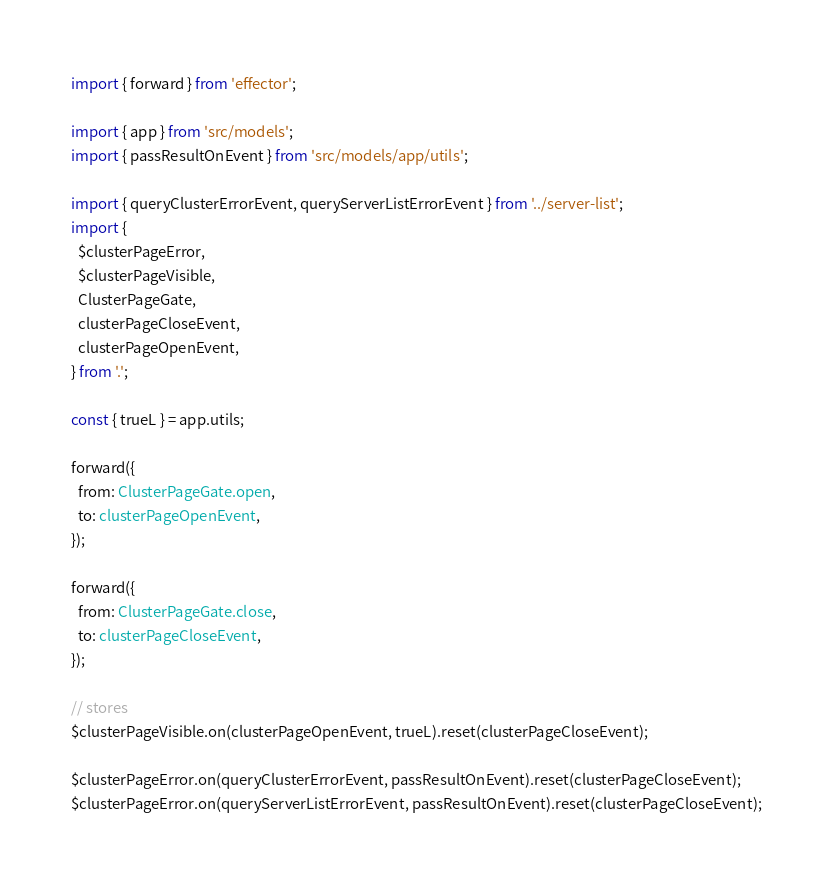<code> <loc_0><loc_0><loc_500><loc_500><_TypeScript_>import { forward } from 'effector';

import { app } from 'src/models';
import { passResultOnEvent } from 'src/models/app/utils';

import { queryClusterErrorEvent, queryServerListErrorEvent } from '../server-list';
import {
  $clusterPageError,
  $clusterPageVisible,
  ClusterPageGate,
  clusterPageCloseEvent,
  clusterPageOpenEvent,
} from '.';

const { trueL } = app.utils;

forward({
  from: ClusterPageGate.open,
  to: clusterPageOpenEvent,
});

forward({
  from: ClusterPageGate.close,
  to: clusterPageCloseEvent,
});

// stores
$clusterPageVisible.on(clusterPageOpenEvent, trueL).reset(clusterPageCloseEvent);

$clusterPageError.on(queryClusterErrorEvent, passResultOnEvent).reset(clusterPageCloseEvent);
$clusterPageError.on(queryServerListErrorEvent, passResultOnEvent).reset(clusterPageCloseEvent);
</code> 